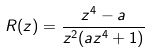Convert formula to latex. <formula><loc_0><loc_0><loc_500><loc_500>R ( z ) = \frac { z ^ { 4 } - a } { z ^ { 2 } ( a z ^ { 4 } + 1 ) }</formula> 